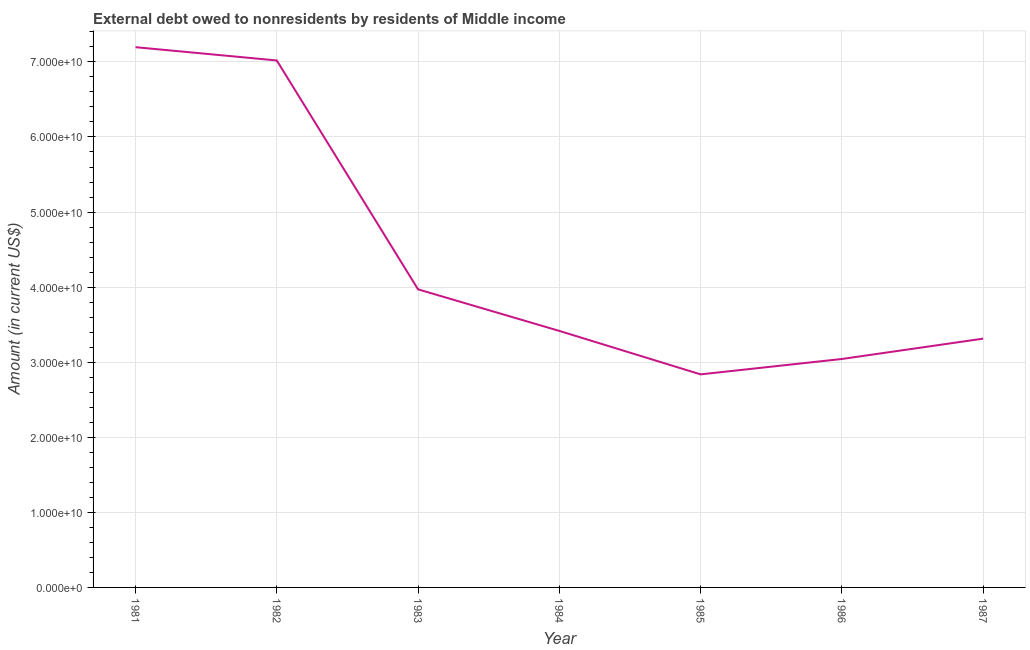What is the debt in 1981?
Make the answer very short. 7.20e+1. Across all years, what is the maximum debt?
Offer a terse response. 7.20e+1. Across all years, what is the minimum debt?
Provide a succinct answer. 2.84e+1. In which year was the debt maximum?
Make the answer very short. 1981. In which year was the debt minimum?
Provide a succinct answer. 1985. What is the sum of the debt?
Keep it short and to the point. 3.08e+11. What is the difference between the debt in 1984 and 1986?
Your answer should be very brief. 3.74e+09. What is the average debt per year?
Offer a terse response. 4.40e+1. What is the median debt?
Offer a terse response. 3.42e+1. Do a majority of the years between 1981 and 1986 (inclusive) have debt greater than 30000000000 US$?
Your answer should be compact. Yes. What is the ratio of the debt in 1982 to that in 1987?
Make the answer very short. 2.12. Is the debt in 1985 less than that in 1986?
Provide a succinct answer. Yes. What is the difference between the highest and the second highest debt?
Ensure brevity in your answer.  1.77e+09. What is the difference between the highest and the lowest debt?
Provide a succinct answer. 4.36e+1. In how many years, is the debt greater than the average debt taken over all years?
Offer a very short reply. 2. Are the values on the major ticks of Y-axis written in scientific E-notation?
Your response must be concise. Yes. Does the graph contain any zero values?
Ensure brevity in your answer.  No. Does the graph contain grids?
Offer a terse response. Yes. What is the title of the graph?
Offer a terse response. External debt owed to nonresidents by residents of Middle income. What is the label or title of the X-axis?
Offer a terse response. Year. What is the label or title of the Y-axis?
Your response must be concise. Amount (in current US$). What is the Amount (in current US$) of 1981?
Offer a very short reply. 7.20e+1. What is the Amount (in current US$) in 1982?
Offer a terse response. 7.02e+1. What is the Amount (in current US$) in 1983?
Provide a succinct answer. 3.97e+1. What is the Amount (in current US$) of 1984?
Offer a very short reply. 3.42e+1. What is the Amount (in current US$) in 1985?
Provide a short and direct response. 2.84e+1. What is the Amount (in current US$) of 1986?
Give a very brief answer. 3.04e+1. What is the Amount (in current US$) of 1987?
Make the answer very short. 3.31e+1. What is the difference between the Amount (in current US$) in 1981 and 1982?
Provide a succinct answer. 1.77e+09. What is the difference between the Amount (in current US$) in 1981 and 1983?
Offer a very short reply. 3.23e+1. What is the difference between the Amount (in current US$) in 1981 and 1984?
Provide a short and direct response. 3.78e+1. What is the difference between the Amount (in current US$) in 1981 and 1985?
Provide a succinct answer. 4.36e+1. What is the difference between the Amount (in current US$) in 1981 and 1986?
Provide a short and direct response. 4.15e+1. What is the difference between the Amount (in current US$) in 1981 and 1987?
Your answer should be compact. 3.88e+1. What is the difference between the Amount (in current US$) in 1982 and 1983?
Ensure brevity in your answer.  3.05e+1. What is the difference between the Amount (in current US$) in 1982 and 1984?
Offer a terse response. 3.60e+1. What is the difference between the Amount (in current US$) in 1982 and 1985?
Keep it short and to the point. 4.18e+1. What is the difference between the Amount (in current US$) in 1982 and 1986?
Your response must be concise. 3.98e+1. What is the difference between the Amount (in current US$) in 1982 and 1987?
Your answer should be very brief. 3.71e+1. What is the difference between the Amount (in current US$) in 1983 and 1984?
Your answer should be compact. 5.53e+09. What is the difference between the Amount (in current US$) in 1983 and 1985?
Your answer should be very brief. 1.13e+1. What is the difference between the Amount (in current US$) in 1983 and 1986?
Provide a short and direct response. 9.27e+09. What is the difference between the Amount (in current US$) in 1983 and 1987?
Make the answer very short. 6.56e+09. What is the difference between the Amount (in current US$) in 1984 and 1985?
Your answer should be very brief. 5.79e+09. What is the difference between the Amount (in current US$) in 1984 and 1986?
Make the answer very short. 3.74e+09. What is the difference between the Amount (in current US$) in 1984 and 1987?
Your response must be concise. 1.03e+09. What is the difference between the Amount (in current US$) in 1985 and 1986?
Provide a succinct answer. -2.05e+09. What is the difference between the Amount (in current US$) in 1985 and 1987?
Your answer should be compact. -4.76e+09. What is the difference between the Amount (in current US$) in 1986 and 1987?
Ensure brevity in your answer.  -2.71e+09. What is the ratio of the Amount (in current US$) in 1981 to that in 1982?
Provide a short and direct response. 1.02. What is the ratio of the Amount (in current US$) in 1981 to that in 1983?
Make the answer very short. 1.81. What is the ratio of the Amount (in current US$) in 1981 to that in 1984?
Offer a terse response. 2.11. What is the ratio of the Amount (in current US$) in 1981 to that in 1985?
Offer a very short reply. 2.54. What is the ratio of the Amount (in current US$) in 1981 to that in 1986?
Make the answer very short. 2.37. What is the ratio of the Amount (in current US$) in 1981 to that in 1987?
Give a very brief answer. 2.17. What is the ratio of the Amount (in current US$) in 1982 to that in 1983?
Offer a very short reply. 1.77. What is the ratio of the Amount (in current US$) in 1982 to that in 1984?
Offer a terse response. 2.05. What is the ratio of the Amount (in current US$) in 1982 to that in 1985?
Offer a terse response. 2.47. What is the ratio of the Amount (in current US$) in 1982 to that in 1986?
Offer a terse response. 2.31. What is the ratio of the Amount (in current US$) in 1982 to that in 1987?
Provide a succinct answer. 2.12. What is the ratio of the Amount (in current US$) in 1983 to that in 1984?
Ensure brevity in your answer.  1.16. What is the ratio of the Amount (in current US$) in 1983 to that in 1985?
Your answer should be very brief. 1.4. What is the ratio of the Amount (in current US$) in 1983 to that in 1986?
Provide a short and direct response. 1.3. What is the ratio of the Amount (in current US$) in 1983 to that in 1987?
Ensure brevity in your answer.  1.2. What is the ratio of the Amount (in current US$) in 1984 to that in 1985?
Give a very brief answer. 1.2. What is the ratio of the Amount (in current US$) in 1984 to that in 1986?
Provide a succinct answer. 1.12. What is the ratio of the Amount (in current US$) in 1984 to that in 1987?
Offer a very short reply. 1.03. What is the ratio of the Amount (in current US$) in 1985 to that in 1986?
Provide a short and direct response. 0.93. What is the ratio of the Amount (in current US$) in 1985 to that in 1987?
Your answer should be very brief. 0.86. What is the ratio of the Amount (in current US$) in 1986 to that in 1987?
Your answer should be very brief. 0.92. 